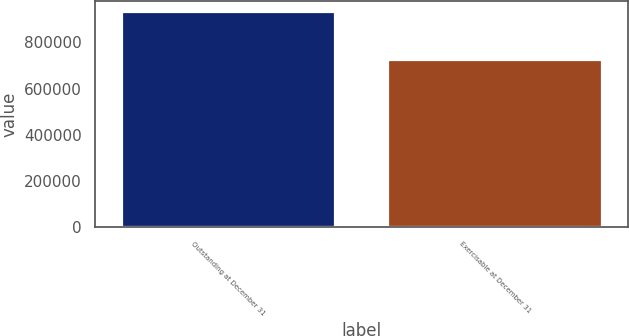Convert chart. <chart><loc_0><loc_0><loc_500><loc_500><bar_chart><fcel>Outstanding at December 31<fcel>Exercisable at December 31<nl><fcel>932748<fcel>725781<nl></chart> 